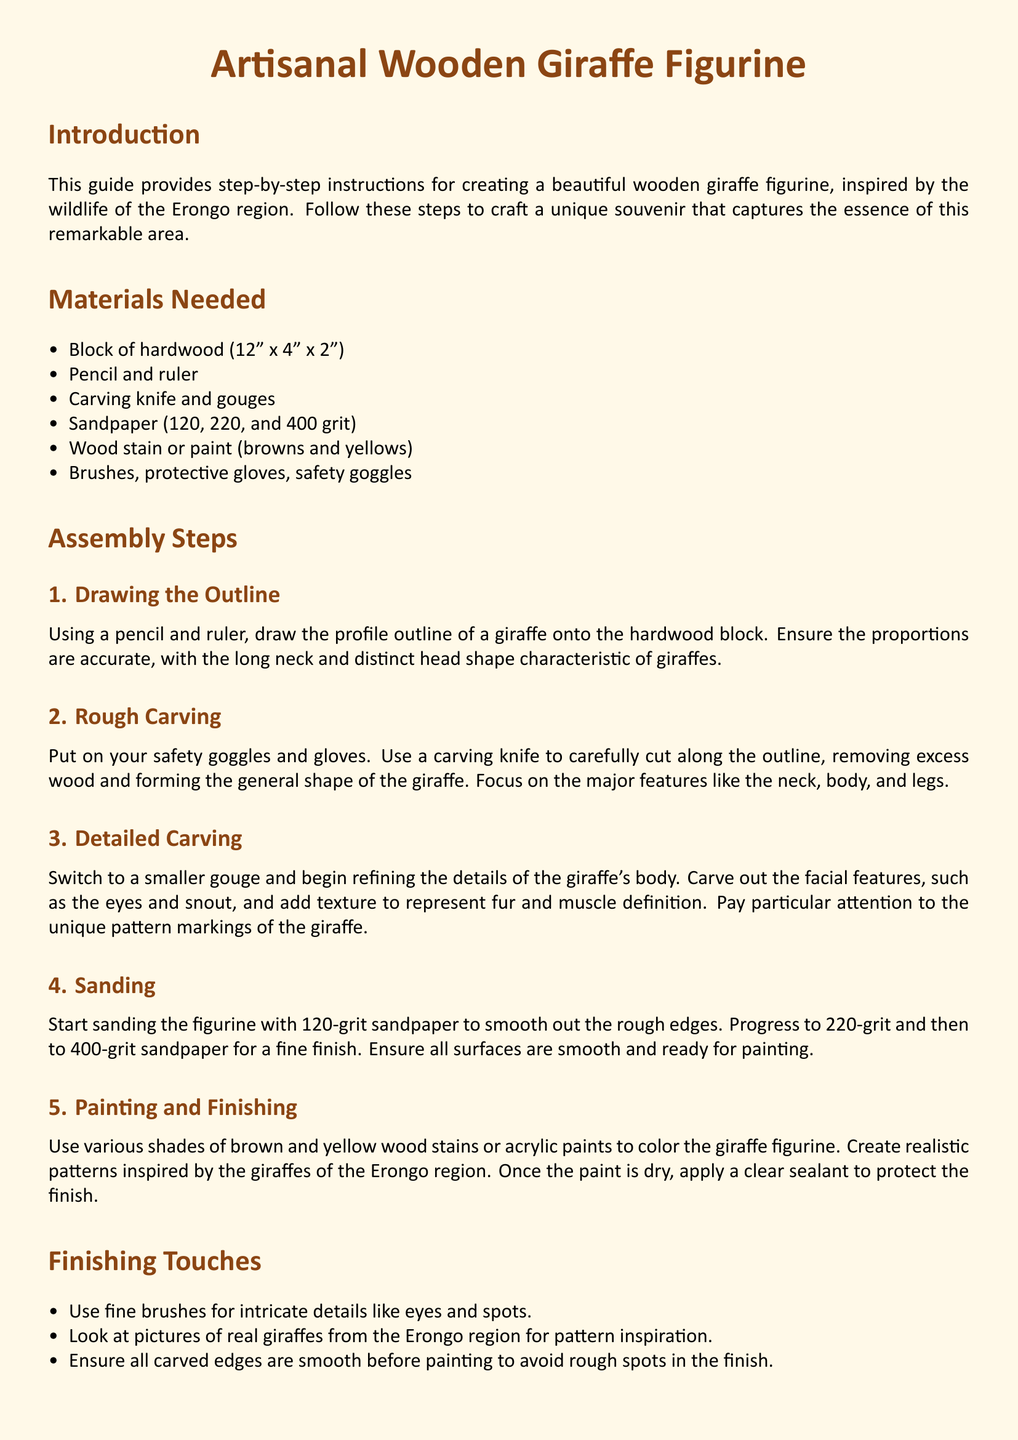What is the size of the hardwood block? The size of the hardwood block is provided in the materials list, which is 12 inches by 4 inches by 2 inches.
Answer: 12" x 4" x 2" Which tools are used for rough carving? The document specifies the tools needed for rough carving in the materials section, highlighting the carving knife as essential.
Answer: Carving knife What grit sandpaper is used first in sanding? The sanding process is detailed in the assembly steps, with 120-grit sandpaper mentioned as the first used.
Answer: 120-grit What should be applied after painting? The finishing touches section specifies a clear sealant that should be applied after the paint is dry to protect the finish.
Answer: Clear sealant How many assembly steps are listed in the document? The assembly steps are enumerated in the guide, and there are five distinct steps outlined.
Answer: 5 What is emphasized for carving intricate details? The finishing touches section notes the use of fine brushes for adding intricate details like eyes and spots.
Answer: Fine brushes Which colors are suggested for painting the giraffe figurine? The paints mentioned in the painting and finishing section include various shades of brown and yellow.
Answer: Browns and yellows What type of figurine is being created? The document's title and introduction define the item being crafted as a wooden giraffe figurine.
Answer: Wooden giraffe figurine 